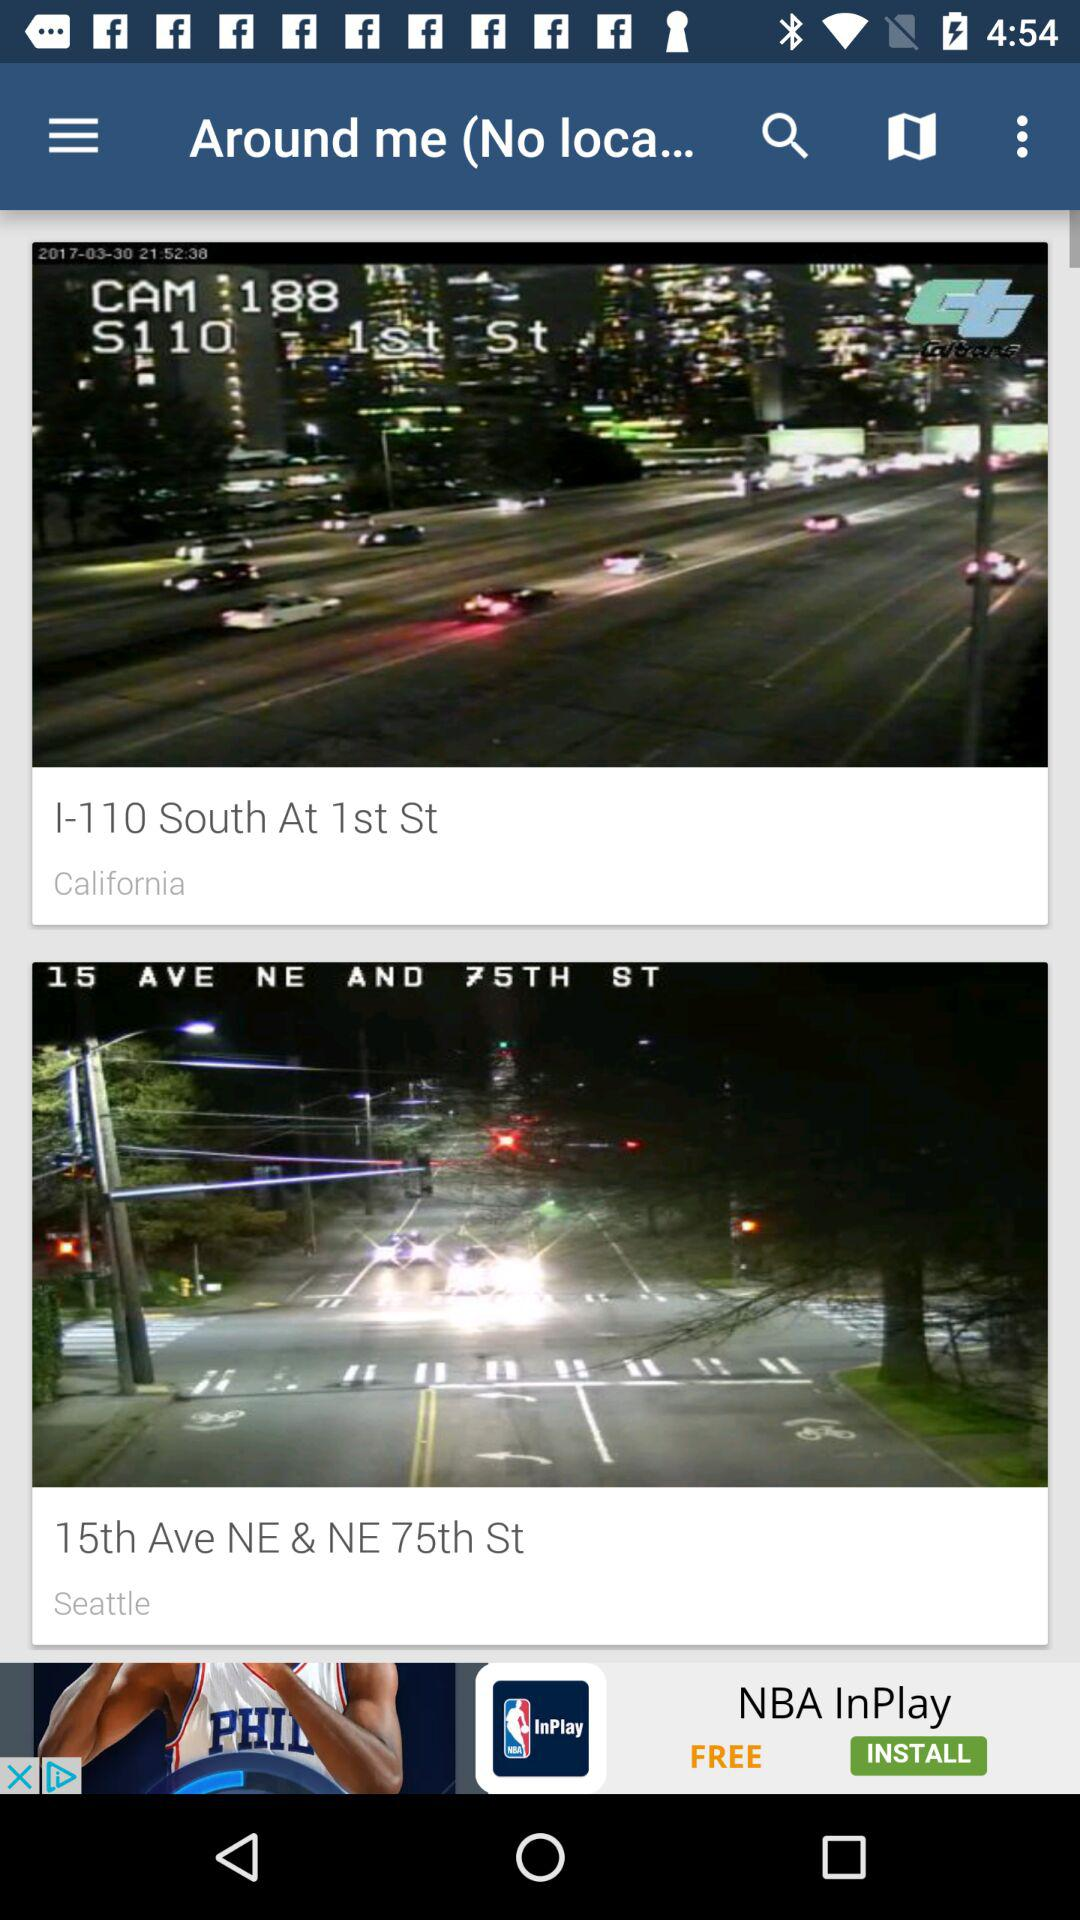Which location is mentioned in Seattle? The mentioned location is 15th Ave. NE & NE 75th St. 